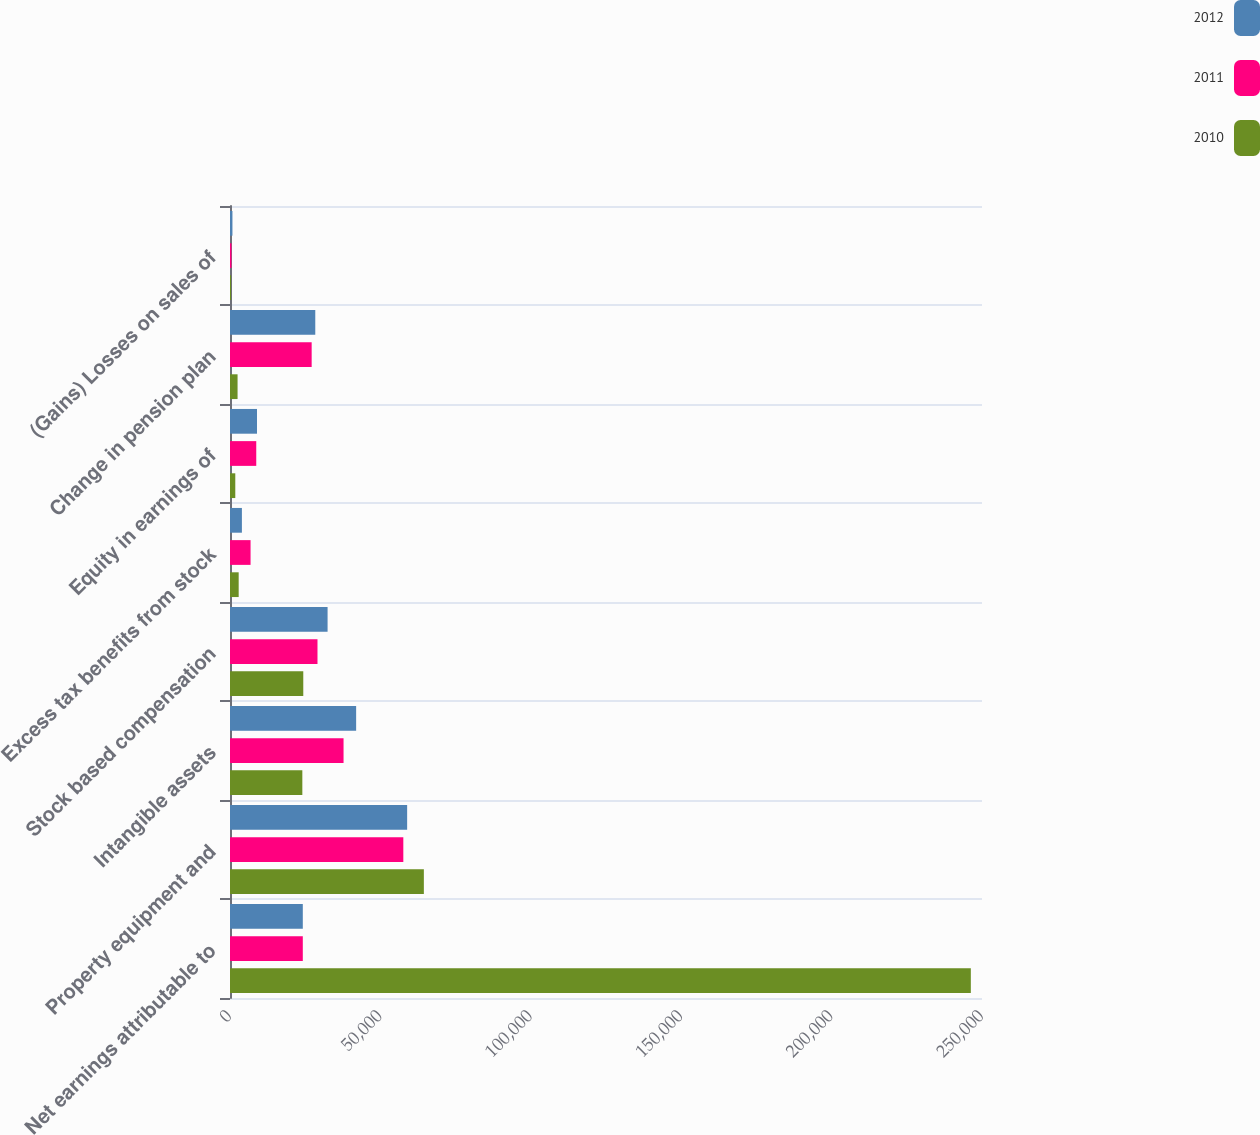<chart> <loc_0><loc_0><loc_500><loc_500><stacked_bar_chart><ecel><fcel>Net earnings attributable to<fcel>Property equipment and<fcel>Intangible assets<fcel>Stock based compensation<fcel>Excess tax benefits from stock<fcel>Equity in earnings of<fcel>Change in pension plan<fcel>(Gains) Losses on sales of<nl><fcel>2012<fcel>24204.5<fcel>58890<fcel>41934<fcel>32442<fcel>3957<fcel>8980<fcel>28351<fcel>811<nl><fcel>2011<fcel>24204.5<fcel>57620<fcel>37750<fcel>29084<fcel>6837<fcel>8729<fcel>27150<fcel>481<nl><fcel>2010<fcel>246287<fcel>64447<fcel>24048<fcel>24361<fcel>2884<fcel>1759<fcel>2516<fcel>353<nl></chart> 